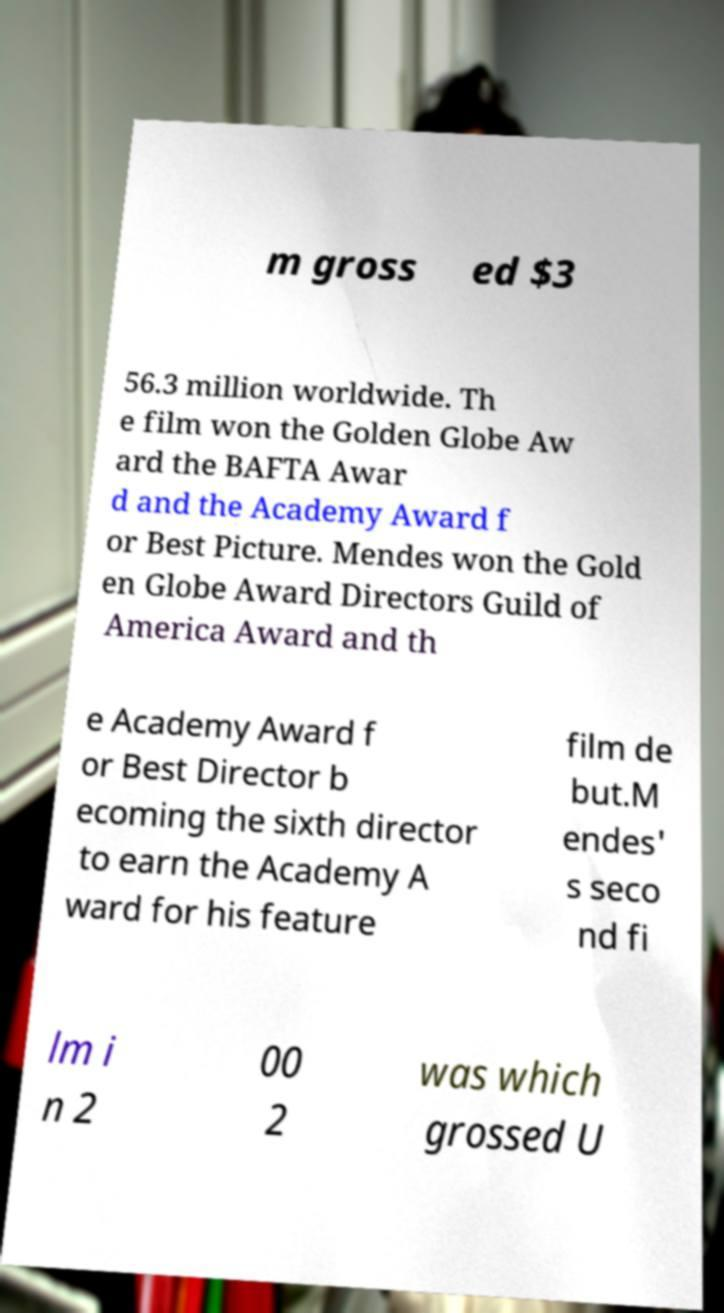For documentation purposes, I need the text within this image transcribed. Could you provide that? m gross ed $3 56.3 million worldwide. Th e film won the Golden Globe Aw ard the BAFTA Awar d and the Academy Award f or Best Picture. Mendes won the Gold en Globe Award Directors Guild of America Award and th e Academy Award f or Best Director b ecoming the sixth director to earn the Academy A ward for his feature film de but.M endes' s seco nd fi lm i n 2 00 2 was which grossed U 